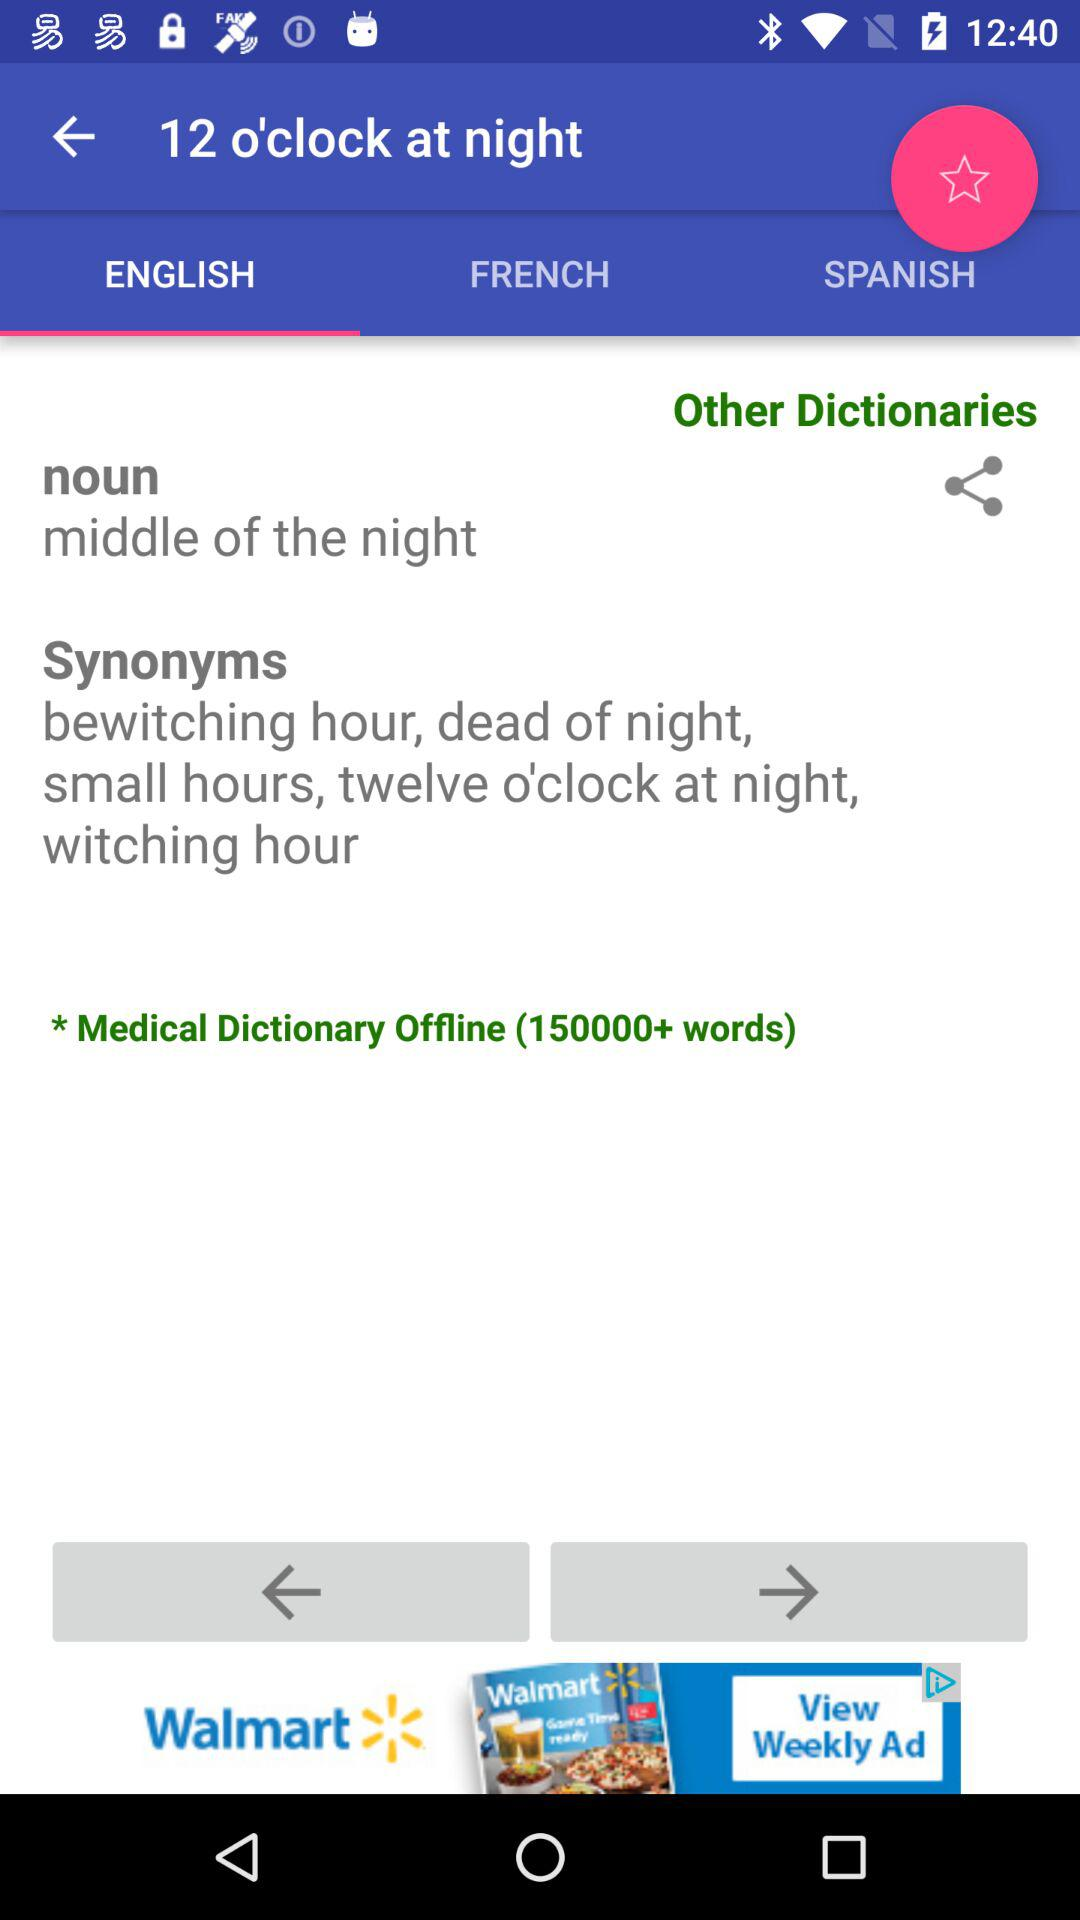Which tab is selected? The selected tab is "English". 